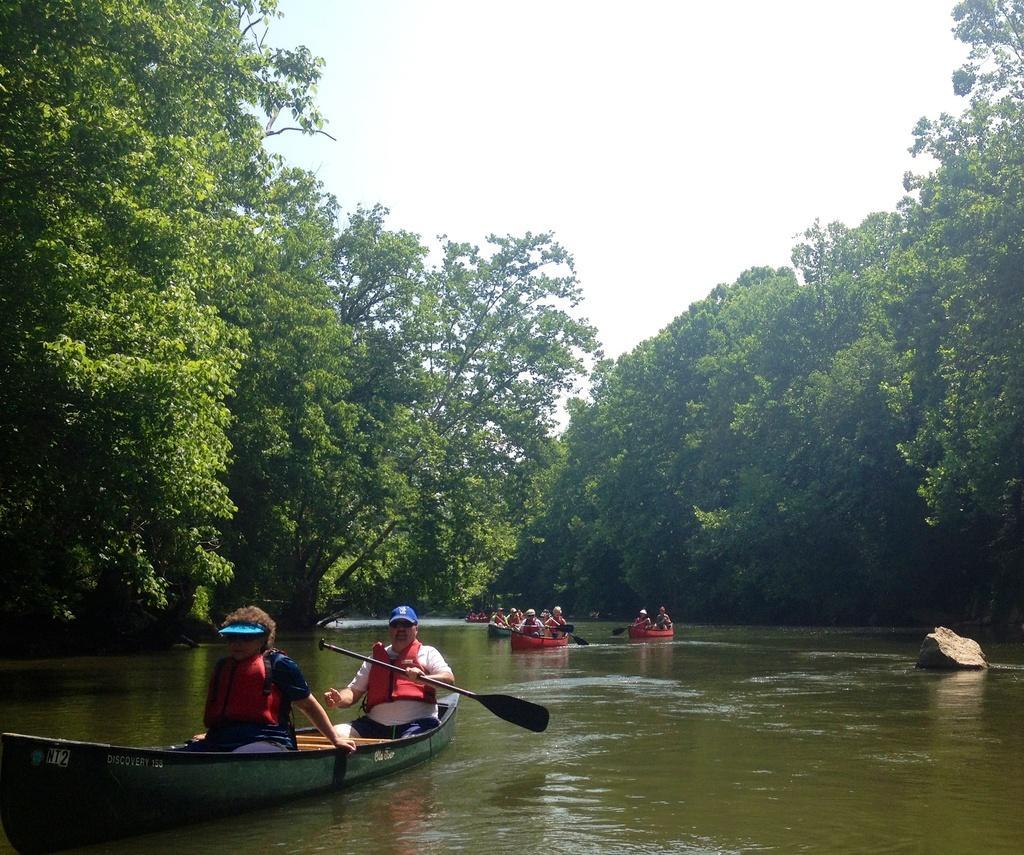How would you summarize this image in a sentence or two? In this picture we can see some people traveling in boats, we can see paddle here, on the right side there is a rock, we can see some trees in the background, there is the sky at the top of the picture. 